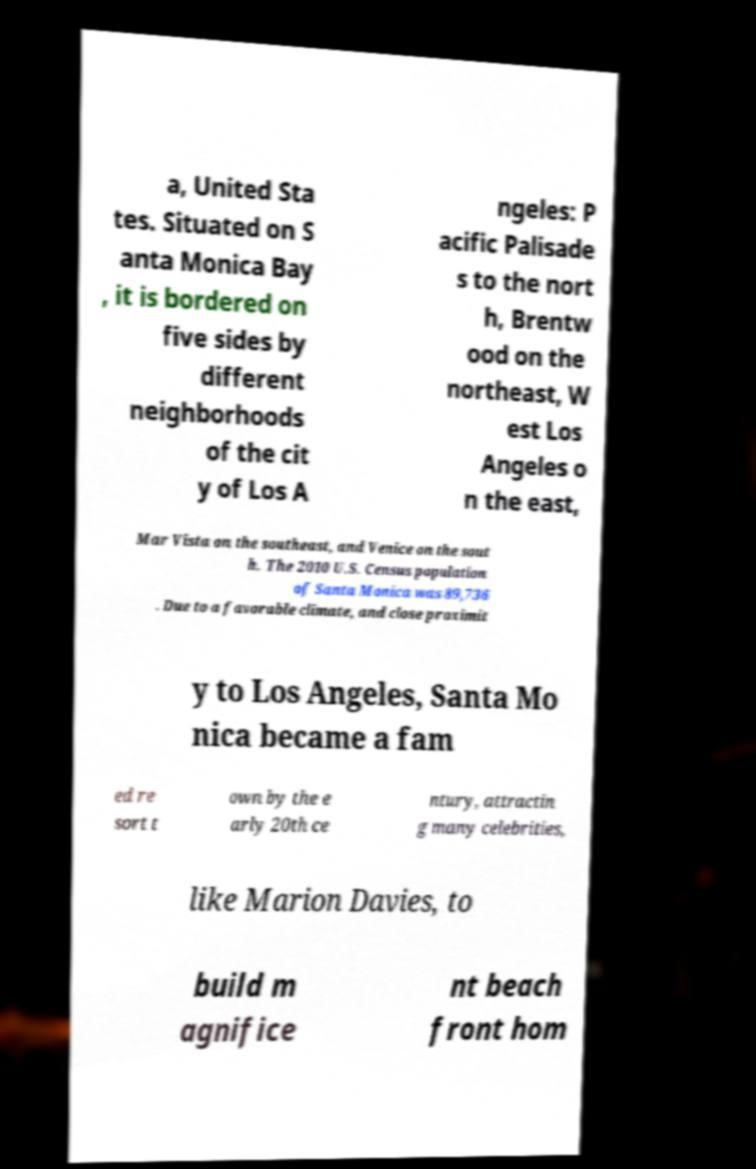For documentation purposes, I need the text within this image transcribed. Could you provide that? a, United Sta tes. Situated on S anta Monica Bay , it is bordered on five sides by different neighborhoods of the cit y of Los A ngeles: P acific Palisade s to the nort h, Brentw ood on the northeast, W est Los Angeles o n the east, Mar Vista on the southeast, and Venice on the sout h. The 2010 U.S. Census population of Santa Monica was 89,736 . Due to a favorable climate, and close proximit y to Los Angeles, Santa Mo nica became a fam ed re sort t own by the e arly 20th ce ntury, attractin g many celebrities, like Marion Davies, to build m agnifice nt beach front hom 